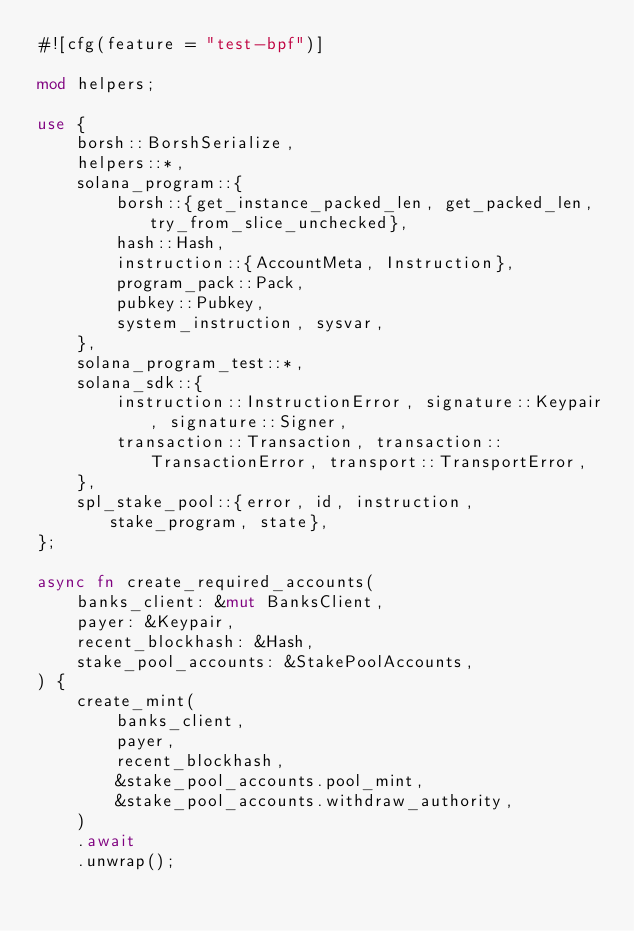<code> <loc_0><loc_0><loc_500><loc_500><_Rust_>#![cfg(feature = "test-bpf")]

mod helpers;

use {
    borsh::BorshSerialize,
    helpers::*,
    solana_program::{
        borsh::{get_instance_packed_len, get_packed_len, try_from_slice_unchecked},
        hash::Hash,
        instruction::{AccountMeta, Instruction},
        program_pack::Pack,
        pubkey::Pubkey,
        system_instruction, sysvar,
    },
    solana_program_test::*,
    solana_sdk::{
        instruction::InstructionError, signature::Keypair, signature::Signer,
        transaction::Transaction, transaction::TransactionError, transport::TransportError,
    },
    spl_stake_pool::{error, id, instruction, stake_program, state},
};

async fn create_required_accounts(
    banks_client: &mut BanksClient,
    payer: &Keypair,
    recent_blockhash: &Hash,
    stake_pool_accounts: &StakePoolAccounts,
) {
    create_mint(
        banks_client,
        payer,
        recent_blockhash,
        &stake_pool_accounts.pool_mint,
        &stake_pool_accounts.withdraw_authority,
    )
    .await
    .unwrap();
</code> 